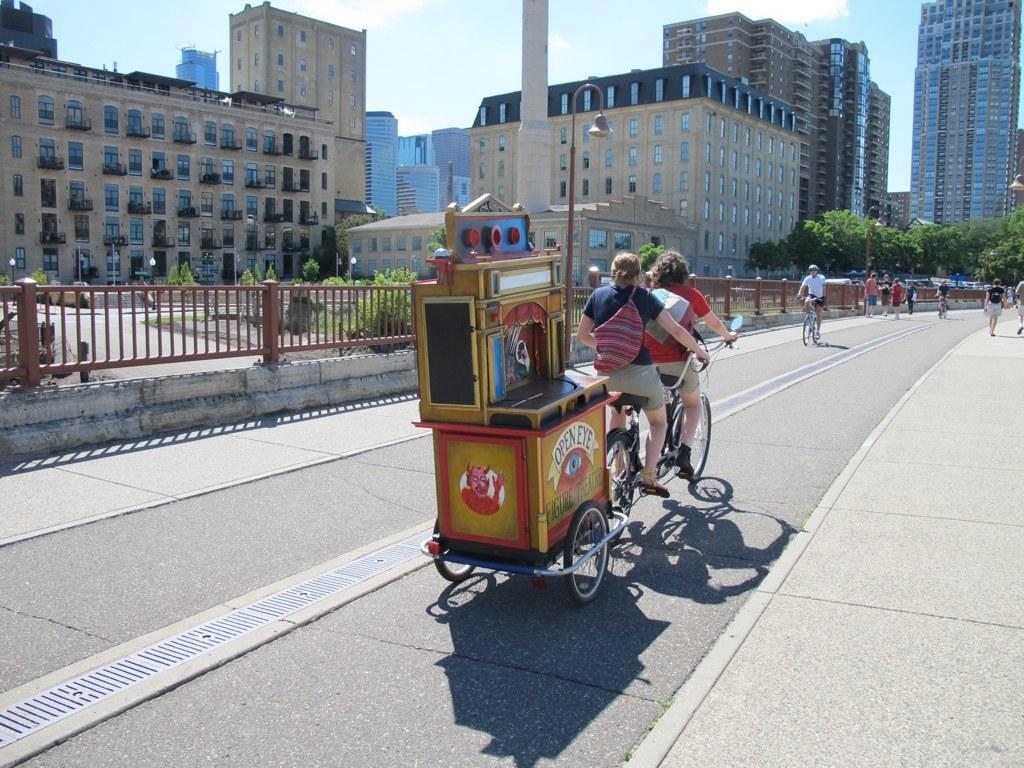Could you give a brief overview of what you see in this image? This is an outside view in this image in the center there are some people who are sitting on cycles and riding, and at the bottom there is a road. In the background there are some buildings, poles, railing and some trees. At the top of the image there is sky. 